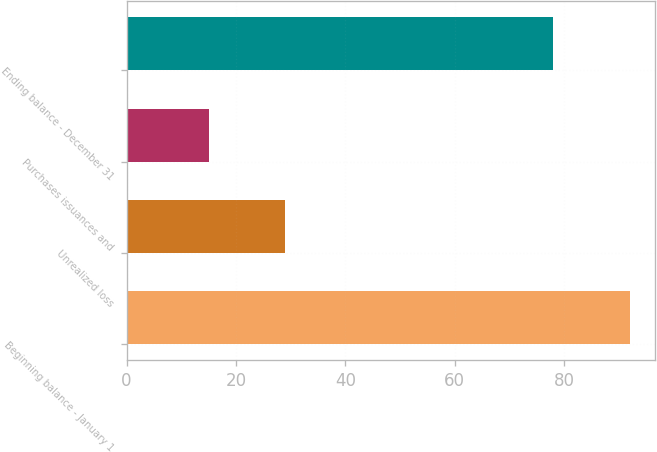Convert chart to OTSL. <chart><loc_0><loc_0><loc_500><loc_500><bar_chart><fcel>Beginning balance - January 1<fcel>Unrealized loss<fcel>Purchases issuances and<fcel>Ending balance - December 31<nl><fcel>92<fcel>29<fcel>15<fcel>78<nl></chart> 